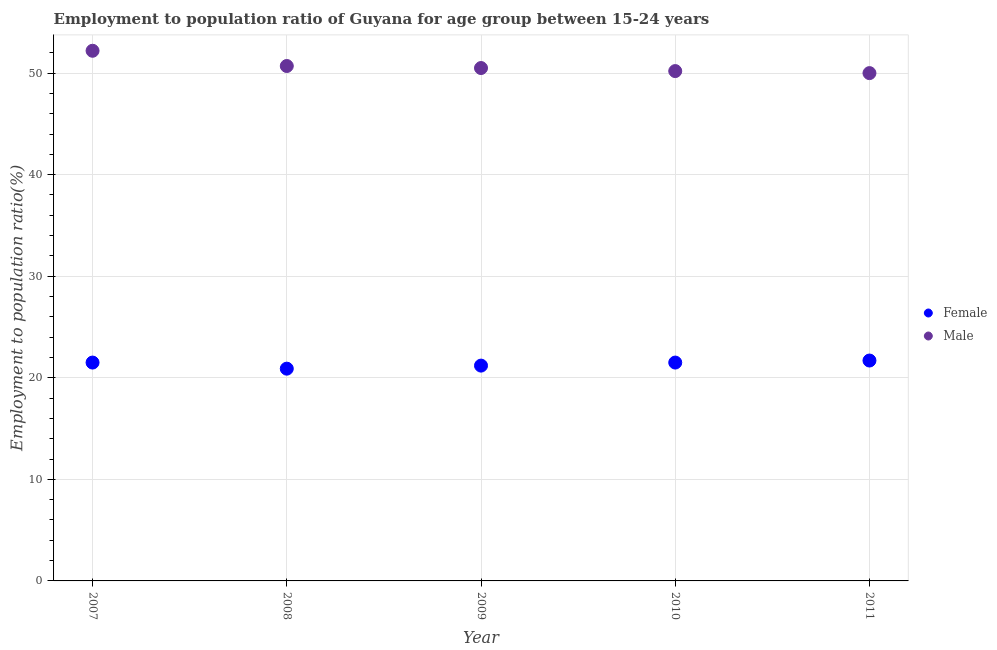Is the number of dotlines equal to the number of legend labels?
Offer a terse response. Yes. Across all years, what is the maximum employment to population ratio(male)?
Ensure brevity in your answer.  52.2. Across all years, what is the minimum employment to population ratio(female)?
Provide a short and direct response. 20.9. In which year was the employment to population ratio(female) maximum?
Provide a short and direct response. 2011. What is the total employment to population ratio(female) in the graph?
Ensure brevity in your answer.  106.8. What is the difference between the employment to population ratio(female) in 2009 and that in 2011?
Your response must be concise. -0.5. What is the average employment to population ratio(male) per year?
Your answer should be very brief. 50.72. In the year 2007, what is the difference between the employment to population ratio(male) and employment to population ratio(female)?
Your response must be concise. 30.7. What is the ratio of the employment to population ratio(male) in 2007 to that in 2010?
Your answer should be very brief. 1.04. Is the employment to population ratio(female) in 2007 less than that in 2010?
Give a very brief answer. No. What is the difference between the highest and the second highest employment to population ratio(male)?
Ensure brevity in your answer.  1.5. What is the difference between the highest and the lowest employment to population ratio(female)?
Make the answer very short. 0.8. In how many years, is the employment to population ratio(female) greater than the average employment to population ratio(female) taken over all years?
Ensure brevity in your answer.  3. Is the sum of the employment to population ratio(male) in 2007 and 2009 greater than the maximum employment to population ratio(female) across all years?
Your answer should be compact. Yes. Is the employment to population ratio(male) strictly greater than the employment to population ratio(female) over the years?
Offer a terse response. Yes. How many dotlines are there?
Offer a very short reply. 2. Are the values on the major ticks of Y-axis written in scientific E-notation?
Keep it short and to the point. No. Does the graph contain any zero values?
Provide a short and direct response. No. How are the legend labels stacked?
Provide a short and direct response. Vertical. What is the title of the graph?
Offer a very short reply. Employment to population ratio of Guyana for age group between 15-24 years. What is the Employment to population ratio(%) in Female in 2007?
Give a very brief answer. 21.5. What is the Employment to population ratio(%) of Male in 2007?
Provide a short and direct response. 52.2. What is the Employment to population ratio(%) in Female in 2008?
Offer a very short reply. 20.9. What is the Employment to population ratio(%) in Male in 2008?
Your answer should be very brief. 50.7. What is the Employment to population ratio(%) of Female in 2009?
Keep it short and to the point. 21.2. What is the Employment to population ratio(%) in Male in 2009?
Offer a terse response. 50.5. What is the Employment to population ratio(%) of Female in 2010?
Offer a terse response. 21.5. What is the Employment to population ratio(%) of Male in 2010?
Provide a short and direct response. 50.2. What is the Employment to population ratio(%) of Female in 2011?
Offer a very short reply. 21.7. What is the Employment to population ratio(%) of Male in 2011?
Your answer should be compact. 50. Across all years, what is the maximum Employment to population ratio(%) in Female?
Your answer should be compact. 21.7. Across all years, what is the maximum Employment to population ratio(%) in Male?
Give a very brief answer. 52.2. Across all years, what is the minimum Employment to population ratio(%) in Female?
Your response must be concise. 20.9. Across all years, what is the minimum Employment to population ratio(%) of Male?
Give a very brief answer. 50. What is the total Employment to population ratio(%) of Female in the graph?
Make the answer very short. 106.8. What is the total Employment to population ratio(%) in Male in the graph?
Give a very brief answer. 253.6. What is the difference between the Employment to population ratio(%) of Male in 2007 and that in 2008?
Ensure brevity in your answer.  1.5. What is the difference between the Employment to population ratio(%) in Female in 2007 and that in 2009?
Offer a very short reply. 0.3. What is the difference between the Employment to population ratio(%) of Female in 2007 and that in 2010?
Keep it short and to the point. 0. What is the difference between the Employment to population ratio(%) of Male in 2007 and that in 2011?
Offer a very short reply. 2.2. What is the difference between the Employment to population ratio(%) of Female in 2008 and that in 2009?
Your answer should be compact. -0.3. What is the difference between the Employment to population ratio(%) in Male in 2008 and that in 2010?
Provide a short and direct response. 0.5. What is the difference between the Employment to population ratio(%) of Female in 2010 and that in 2011?
Give a very brief answer. -0.2. What is the difference between the Employment to population ratio(%) of Female in 2007 and the Employment to population ratio(%) of Male in 2008?
Provide a short and direct response. -29.2. What is the difference between the Employment to population ratio(%) of Female in 2007 and the Employment to population ratio(%) of Male in 2010?
Ensure brevity in your answer.  -28.7. What is the difference between the Employment to population ratio(%) in Female in 2007 and the Employment to population ratio(%) in Male in 2011?
Give a very brief answer. -28.5. What is the difference between the Employment to population ratio(%) of Female in 2008 and the Employment to population ratio(%) of Male in 2009?
Your answer should be very brief. -29.6. What is the difference between the Employment to population ratio(%) in Female in 2008 and the Employment to population ratio(%) in Male in 2010?
Offer a very short reply. -29.3. What is the difference between the Employment to population ratio(%) in Female in 2008 and the Employment to population ratio(%) in Male in 2011?
Provide a succinct answer. -29.1. What is the difference between the Employment to population ratio(%) of Female in 2009 and the Employment to population ratio(%) of Male in 2010?
Keep it short and to the point. -29. What is the difference between the Employment to population ratio(%) in Female in 2009 and the Employment to population ratio(%) in Male in 2011?
Your answer should be compact. -28.8. What is the difference between the Employment to population ratio(%) in Female in 2010 and the Employment to population ratio(%) in Male in 2011?
Ensure brevity in your answer.  -28.5. What is the average Employment to population ratio(%) in Female per year?
Ensure brevity in your answer.  21.36. What is the average Employment to population ratio(%) of Male per year?
Make the answer very short. 50.72. In the year 2007, what is the difference between the Employment to population ratio(%) of Female and Employment to population ratio(%) of Male?
Ensure brevity in your answer.  -30.7. In the year 2008, what is the difference between the Employment to population ratio(%) of Female and Employment to population ratio(%) of Male?
Your answer should be compact. -29.8. In the year 2009, what is the difference between the Employment to population ratio(%) of Female and Employment to population ratio(%) of Male?
Keep it short and to the point. -29.3. In the year 2010, what is the difference between the Employment to population ratio(%) in Female and Employment to population ratio(%) in Male?
Provide a short and direct response. -28.7. In the year 2011, what is the difference between the Employment to population ratio(%) of Female and Employment to population ratio(%) of Male?
Your response must be concise. -28.3. What is the ratio of the Employment to population ratio(%) of Female in 2007 to that in 2008?
Provide a succinct answer. 1.03. What is the ratio of the Employment to population ratio(%) of Male in 2007 to that in 2008?
Offer a very short reply. 1.03. What is the ratio of the Employment to population ratio(%) of Female in 2007 to that in 2009?
Ensure brevity in your answer.  1.01. What is the ratio of the Employment to population ratio(%) of Male in 2007 to that in 2009?
Offer a very short reply. 1.03. What is the ratio of the Employment to population ratio(%) in Male in 2007 to that in 2010?
Ensure brevity in your answer.  1.04. What is the ratio of the Employment to population ratio(%) in Male in 2007 to that in 2011?
Your answer should be compact. 1.04. What is the ratio of the Employment to population ratio(%) of Female in 2008 to that in 2009?
Your answer should be very brief. 0.99. What is the ratio of the Employment to population ratio(%) of Male in 2008 to that in 2009?
Your answer should be compact. 1. What is the ratio of the Employment to population ratio(%) in Female in 2008 to that in 2010?
Give a very brief answer. 0.97. What is the ratio of the Employment to population ratio(%) of Male in 2008 to that in 2010?
Provide a succinct answer. 1.01. What is the ratio of the Employment to population ratio(%) in Female in 2008 to that in 2011?
Your response must be concise. 0.96. What is the ratio of the Employment to population ratio(%) of Male in 2010 to that in 2011?
Your answer should be compact. 1. What is the difference between the highest and the second highest Employment to population ratio(%) in Male?
Your response must be concise. 1.5. 